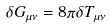<formula> <loc_0><loc_0><loc_500><loc_500>\delta G _ { \mu \nu } = 8 \pi \delta T _ { \mu \nu }</formula> 